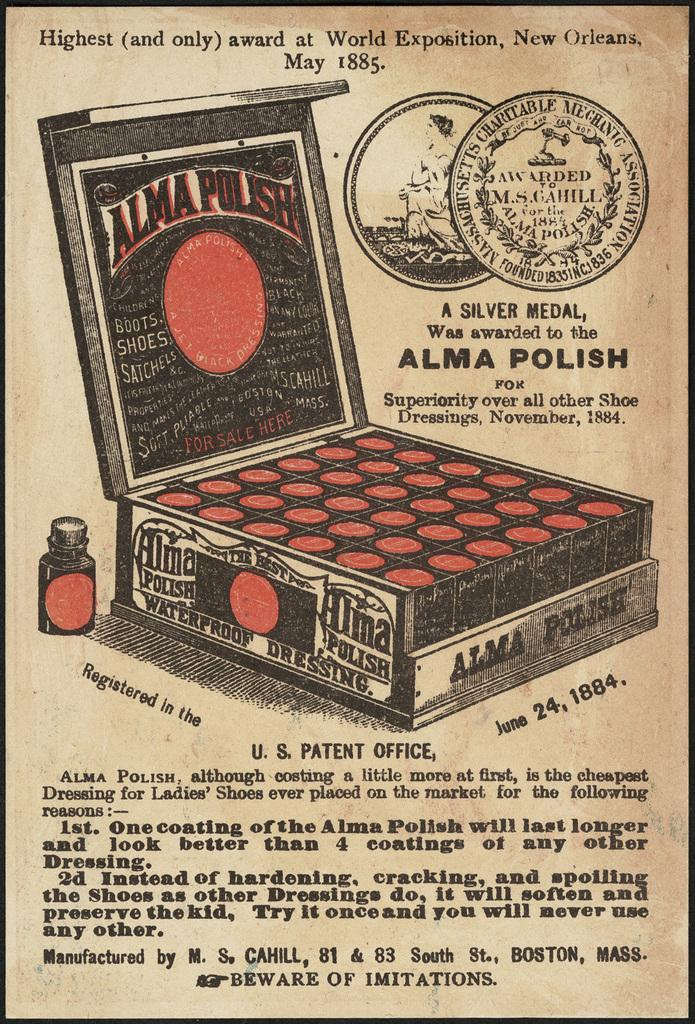<image>
Describe the image concisely. Highest and only award at World Exposition, New Orleans May 1885, Alma Polish product. 